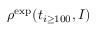Convert formula to latex. <formula><loc_0><loc_0><loc_500><loc_500>\rho ^ { e x p } ( t _ { i \geq 1 0 0 } , I )</formula> 